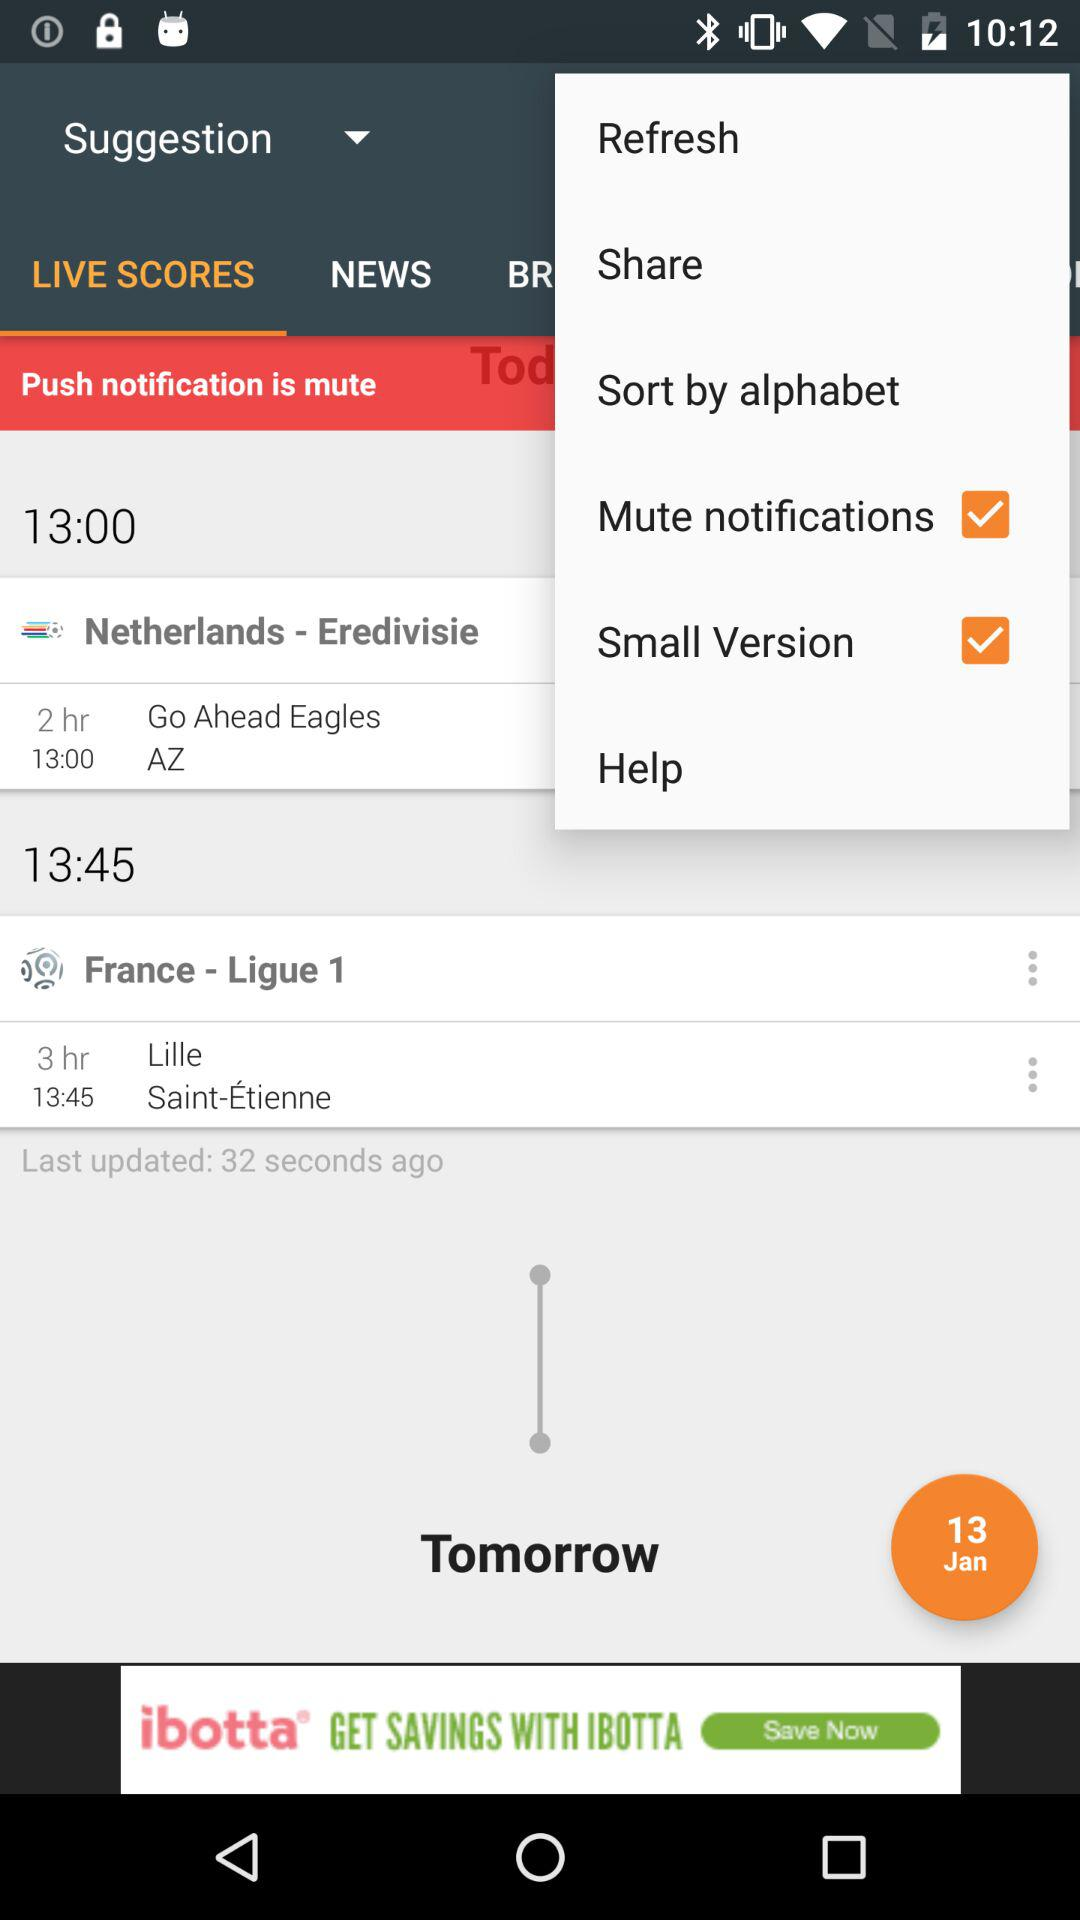When was it last updated? It was last updated 32 seconds ago. 